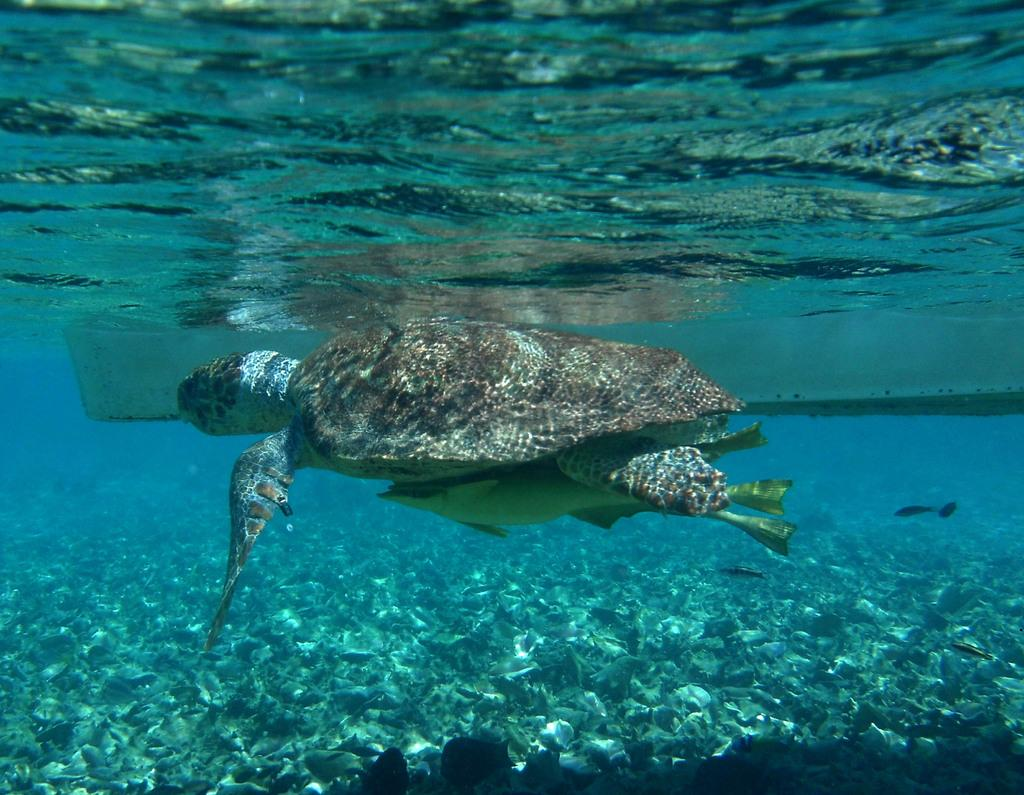What type of animals are present in the image? There are tortoises in the image. What is the environment in which the tortoises are located? The tortoises are in green and blue color water. Can you describe any other elements in the image? Yes, there are objects visible in the image. Is there a crown visible on any of the tortoises in the image? No, there is no crown present on any of the tortoises in the image. 